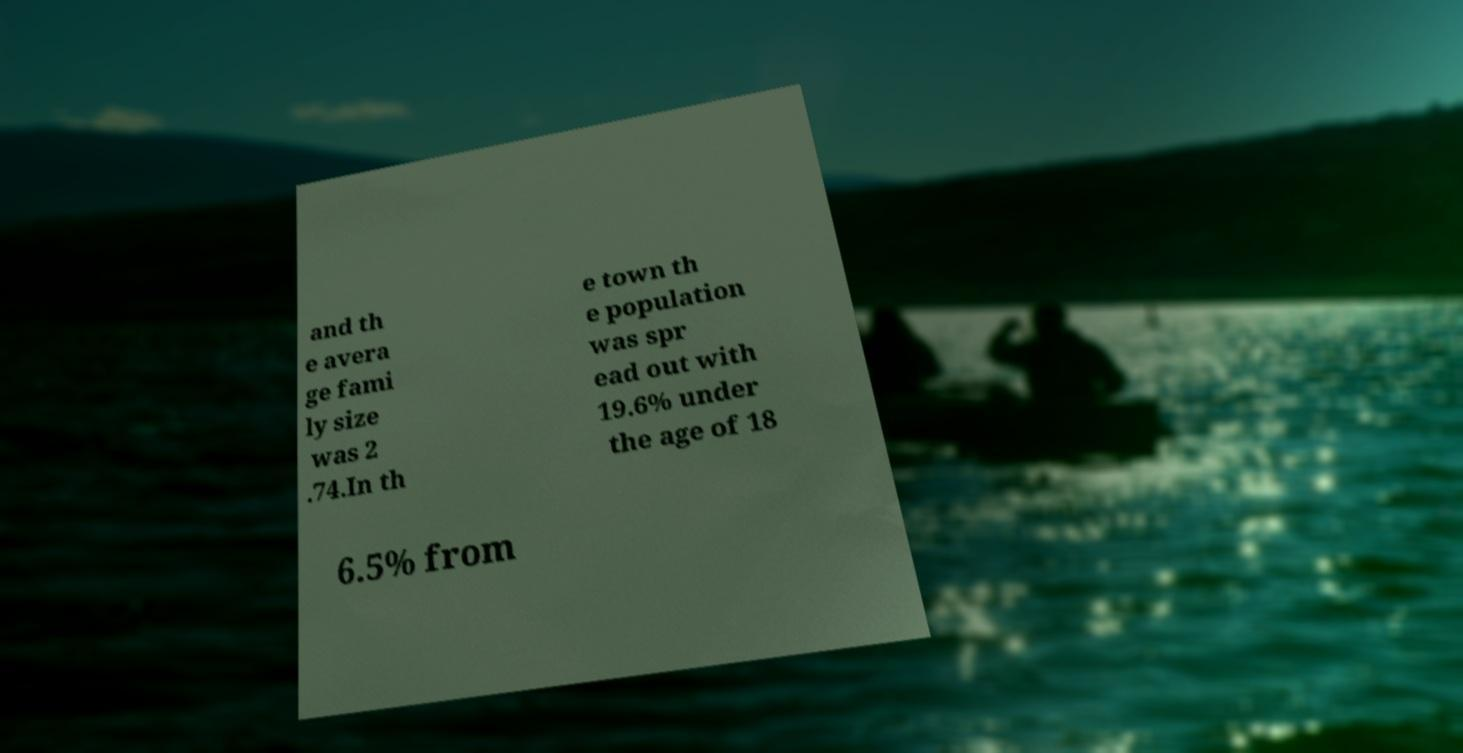What messages or text are displayed in this image? I need them in a readable, typed format. and th e avera ge fami ly size was 2 .74.In th e town th e population was spr ead out with 19.6% under the age of 18 6.5% from 